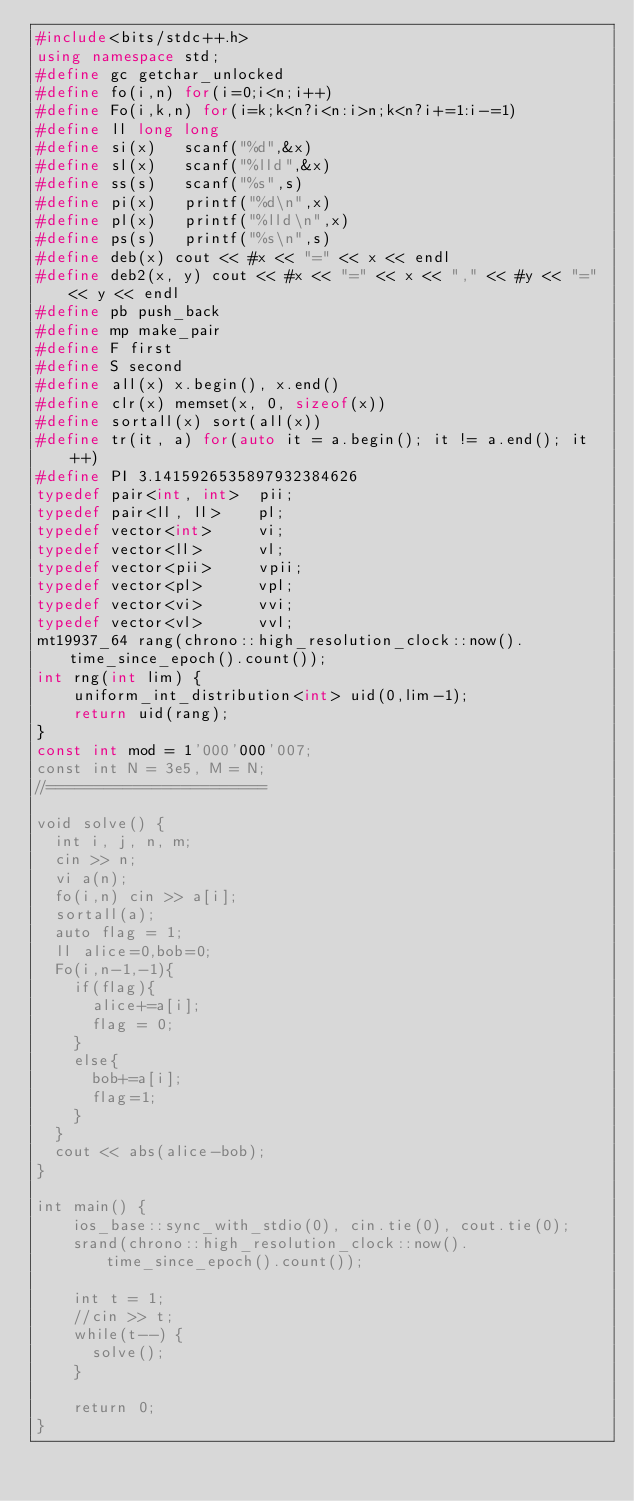Convert code to text. <code><loc_0><loc_0><loc_500><loc_500><_C++_>#include<bits/stdc++.h>
using namespace std;
#define gc getchar_unlocked
#define fo(i,n) for(i=0;i<n;i++)
#define Fo(i,k,n) for(i=k;k<n?i<n:i>n;k<n?i+=1:i-=1)
#define ll long long
#define si(x)	scanf("%d",&x)
#define sl(x)	scanf("%lld",&x)
#define ss(s)	scanf("%s",s)
#define pi(x)	printf("%d\n",x)
#define pl(x)	printf("%lld\n",x)
#define ps(s)	printf("%s\n",s)
#define deb(x) cout << #x << "=" << x << endl
#define deb2(x, y) cout << #x << "=" << x << "," << #y << "=" << y << endl
#define pb push_back
#define mp make_pair
#define F first
#define S second
#define all(x) x.begin(), x.end()
#define clr(x) memset(x, 0, sizeof(x))
#define sortall(x) sort(all(x))
#define tr(it, a) for(auto it = a.begin(); it != a.end(); it++)
#define PI 3.1415926535897932384626
typedef pair<int, int>	pii;
typedef pair<ll, ll>	pl;
typedef vector<int>		vi;
typedef vector<ll>		vl;
typedef vector<pii>		vpii;
typedef vector<pl>		vpl;
typedef vector<vi>		vvi;
typedef vector<vl>		vvl;
mt19937_64 rang(chrono::high_resolution_clock::now().time_since_epoch().count());
int rng(int lim) {
	uniform_int_distribution<int> uid(0,lim-1);
	return uid(rang);
}
const int mod = 1'000'000'007;
const int N = 3e5, M = N;
//=======================

void solve() {
  int i, j, n, m;
  cin >> n;
  vi a(n);
  fo(i,n) cin >> a[i];
  sortall(a);
  auto flag = 1;
  ll alice=0,bob=0;
  Fo(i,n-1,-1){
    if(flag){
      alice+=a[i];
      flag = 0;
    }
    else{
      bob+=a[i];
      flag=1;
    }
  }
  cout << abs(alice-bob);
}

int main() {
    ios_base::sync_with_stdio(0), cin.tie(0), cout.tie(0);
    srand(chrono::high_resolution_clock::now().time_since_epoch().count());

    int t = 1;
    //cin >> t;
    while(t--) {
      solve();
    }

    return 0;
}
</code> 